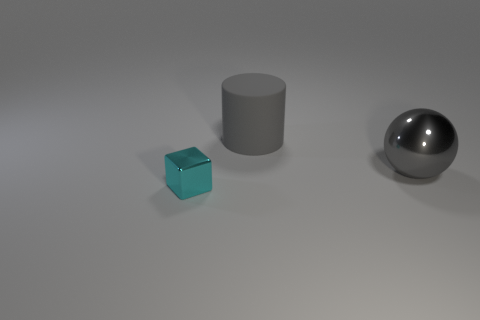Add 3 tiny shiny objects. How many objects exist? 6 Subtract all cylinders. How many objects are left? 2 Add 2 large gray shiny cylinders. How many large gray shiny cylinders exist? 2 Subtract 0 brown balls. How many objects are left? 3 Subtract all big metal objects. Subtract all small blocks. How many objects are left? 1 Add 3 tiny cyan things. How many tiny cyan things are left? 4 